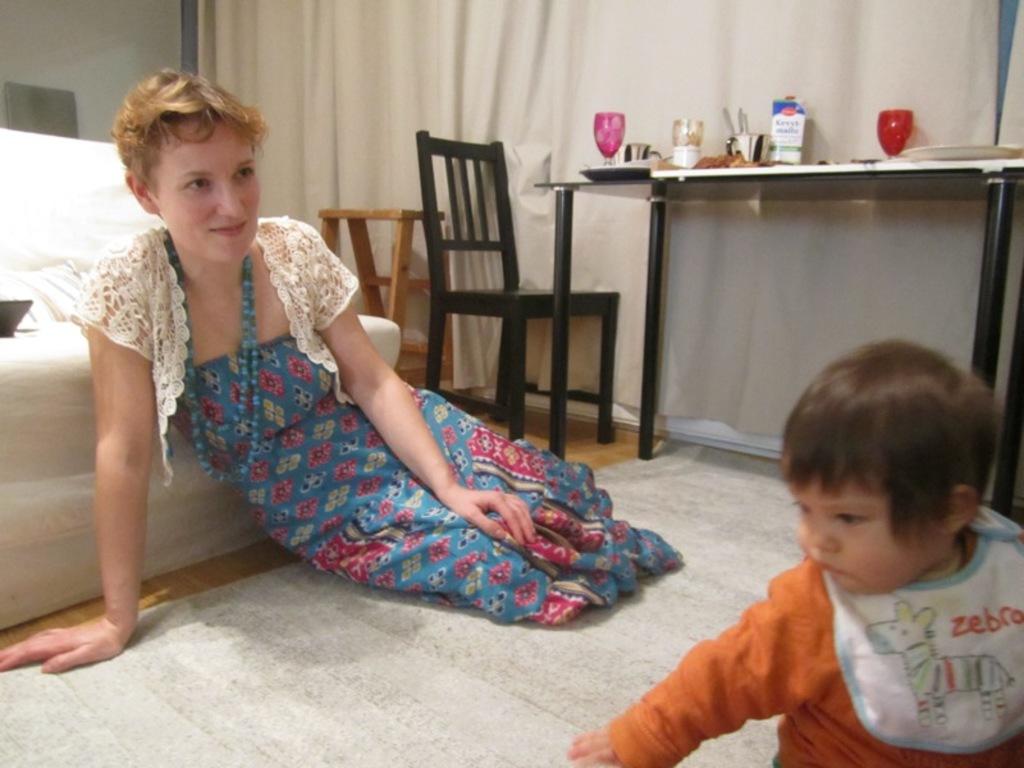What does the bib say?
Your answer should be compact. Zebra. 